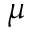Convert formula to latex. <formula><loc_0><loc_0><loc_500><loc_500>\mu</formula> 